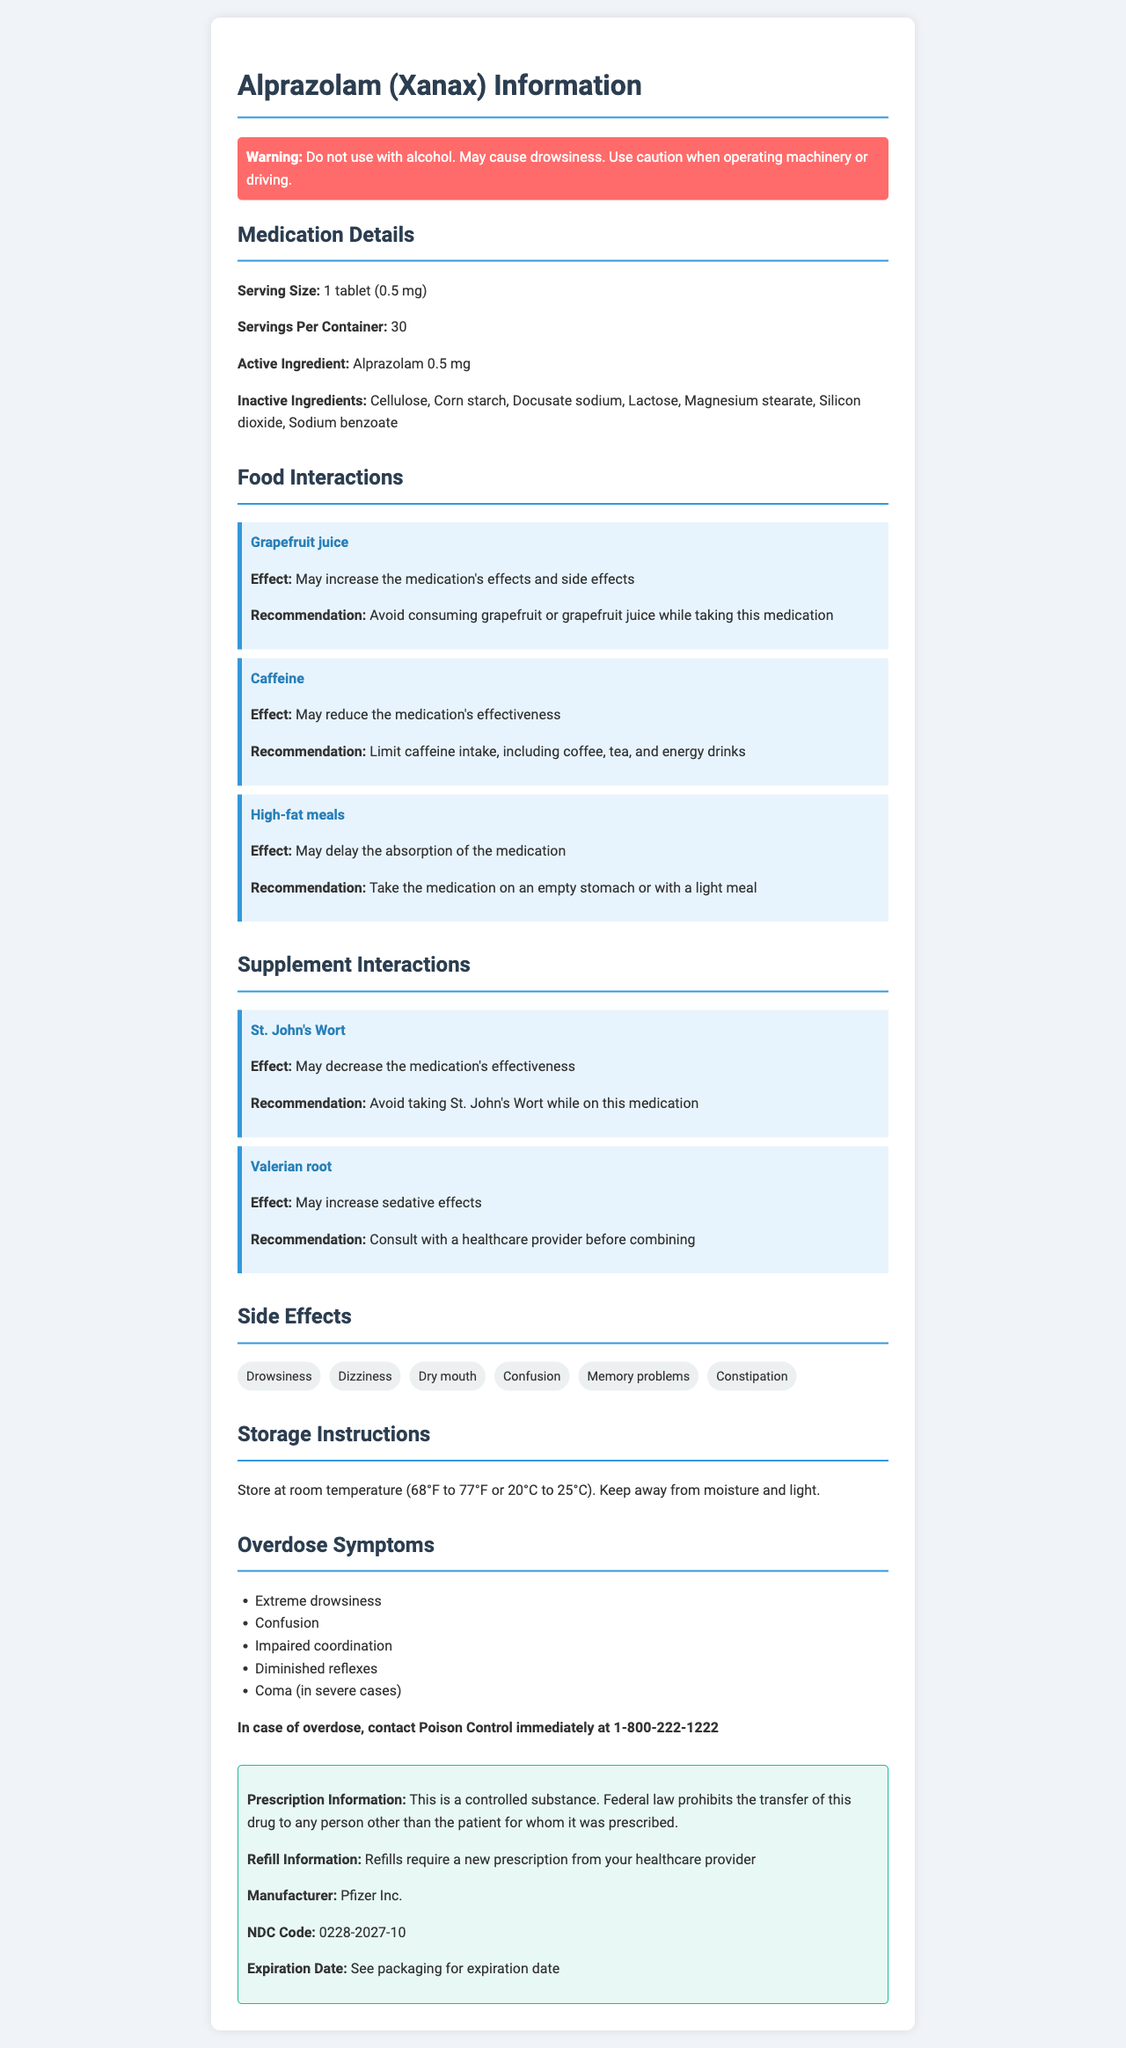what is the active ingredient in Alprazolam (Xanax)? The document lists the active ingredient as "Alprazolam 0.5 mg" in the Medication Details section.
Answer: Alprazolam 0.5 mg what should be avoided while taking this medication? The warning section advises against using alcohol, and the food interactions section recommends avoiding grapefruit juice.
Answer: Alcohol and grapefruit juice what is the recommended action if an overdose occurs? The document mentions to contact Poison Control immediately at 1-800-222-1222 in case of an overdose.
Answer: Contact Poison Control at 1-800-222-1222 what are some potential side effects of this medication? The side effects section lists these effects explicitly as potential side effects.
Answer: Drowsiness, dizziness, dry mouth, confusion, memory problems, constipation how should Alprazolam (Xanax) be stored? The storage instructions section provides this specific information.
Answer: Store at room temperature (68°F to 77°F or 20°C to 25°C), away from moisture and light what food's intake should be limited while taking this medication? The document mentions that caffeine can reduce the medication's effectiveness, so it should be limited.
Answer: Caffeine which supplement should be consulted with a healthcare provider before combining with this medication? The supplement interactions section mentions that Valerian root may increase sedative effects and advises consulting a healthcare provider before combining them.
Answer: Valerian root which food might delay the absorption of Alprazolam? A. Grapefruit Juice B. High-fat meals C. Dairy products The food interactions section states that high-fat meals may delay the absorption of the medication.
Answer: B which of the following is an inactive ingredient in Alprazolam (Xanax)? 1. Lactose 2. Alprazolam 3. Vitamin D 4. Glucose The inactive ingredients section lists Lactose among the ingredients, while the others are not mentioned.
Answer: 1 can Alprazolam (Xanax) be used while operating machinery or driving? The warning section advises that the medication may cause drowsiness and users should use caution when operating machinery or driving.
Answer: No what precautions should you take while consuming caffeine on this medication? The food interactions section advises limiting caffeine intake as it may reduce the medication's effectiveness.
Answer: Limit caffeine intake, including coffee, tea, and energy drinks is St. John's Wort recommended to be taken with Alprazolam (Xanax)? The supplement interactions section states St. John's Wort may decrease the medication's effectiveness and advises against combining them.
Answer: No summarize the key points of the document The document is a comprehensive medication guide, giving detailed drug information, including usage instructions, interaction risks, side effects, handling overdoses, and storage, ensuring safe and effective use.
Answer: The document provides comprehensive information about Alprazolam (Xanax), highlighting its active and inactive ingredients, cautionary warnings, food and supplement interactions, side effects, storage instructions, overdose actions, and prescription details. Specific precautions include avoiding alcohol and grapefruit juice, limiting caffeine, and consulting a provider before mixing with certain supplements like Valerian root. It emphasizes safety with overdose protocols and driving warnings while detailing how to store the medication and handle refills. what is the exact expiration date of this medication? The exact expiration date is not provided in the document; it says to see the packaging for the expiration date.
Answer: Not enough information 